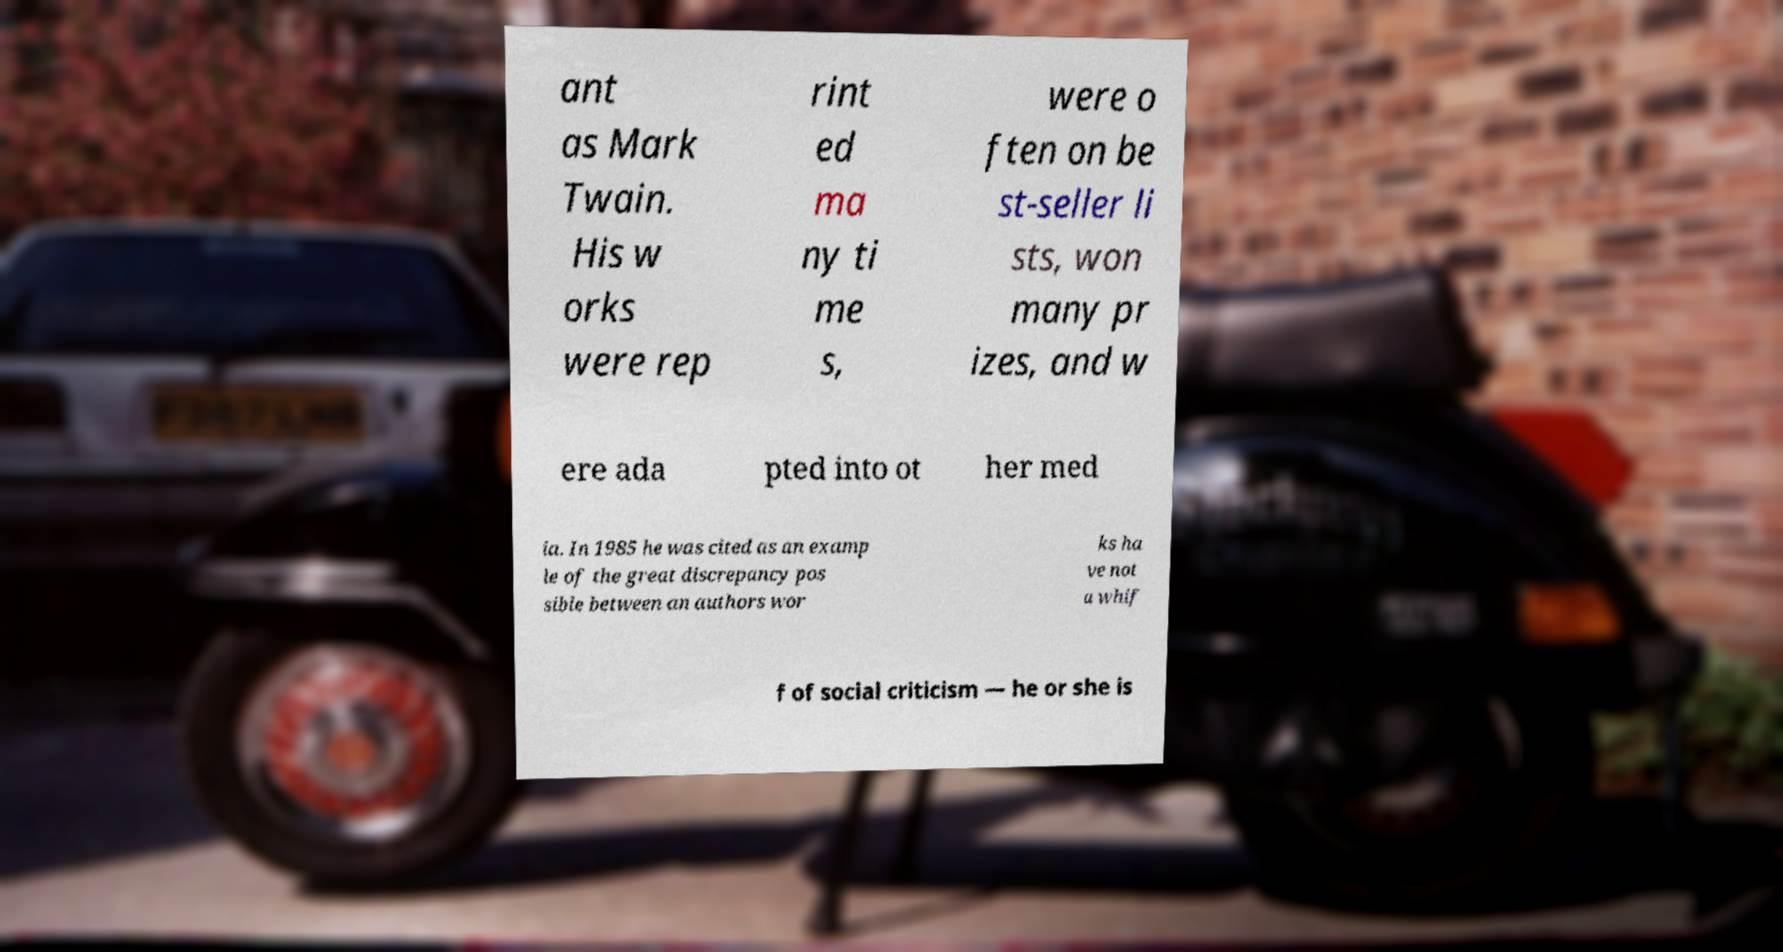Could you extract and type out the text from this image? ant as Mark Twain. His w orks were rep rint ed ma ny ti me s, were o ften on be st-seller li sts, won many pr izes, and w ere ada pted into ot her med ia. In 1985 he was cited as an examp le of the great discrepancy pos sible between an authors wor ks ha ve not a whif f of social criticism — he or she is 